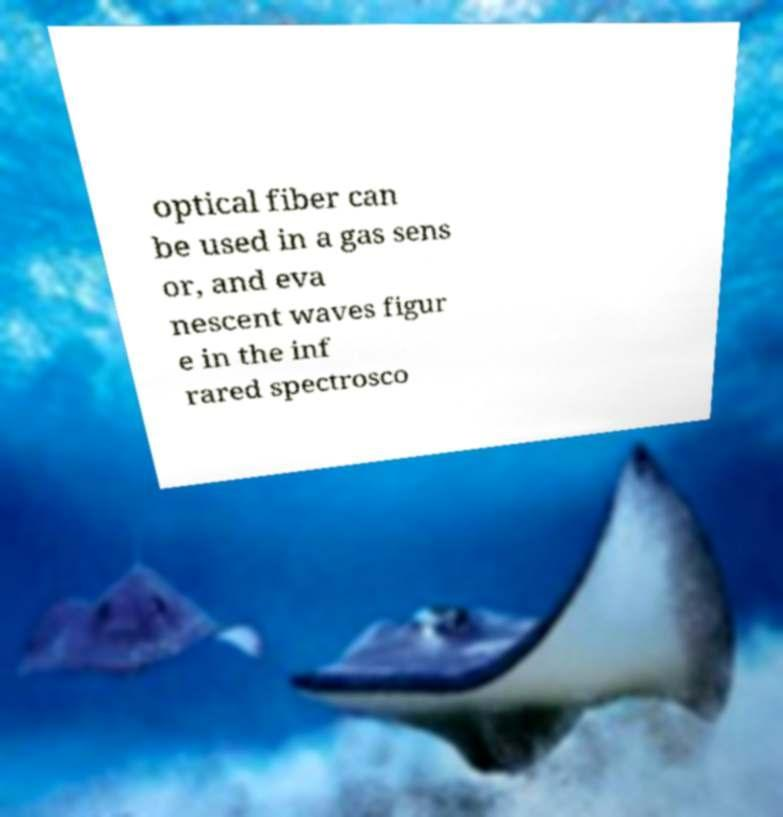What messages or text are displayed in this image? I need them in a readable, typed format. optical fiber can be used in a gas sens or, and eva nescent waves figur e in the inf rared spectrosco 